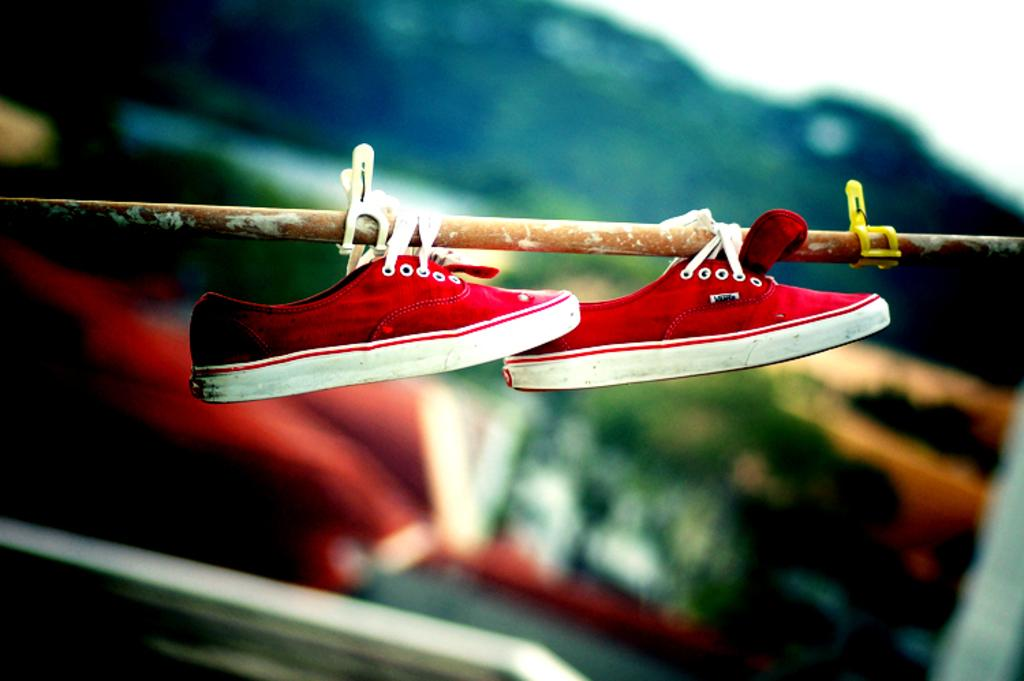What is hanging on the iron fence in the image? There are shoes hanging on an iron fence in the image. Can you describe any additional objects in the image? Yes, there are two clips in the image. What can be observed about the background of the image? The background of the image is blurred. What type of skin can be seen on the beetle in the image? There is no beetle present in the image, so there is no skin to observe. What kind of pancake is being served in the image? There is no pancake present in the image. 